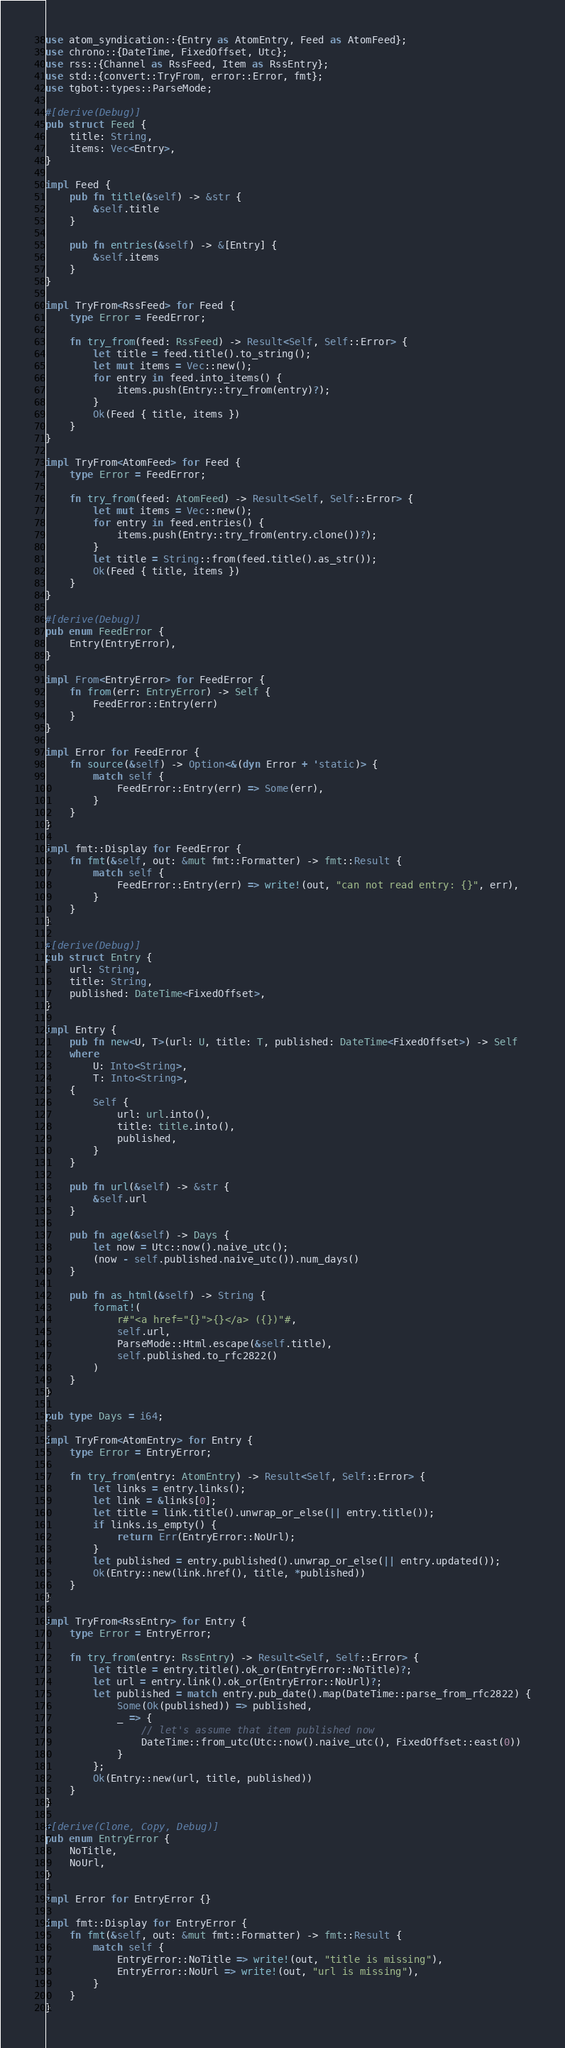<code> <loc_0><loc_0><loc_500><loc_500><_Rust_>use atom_syndication::{Entry as AtomEntry, Feed as AtomFeed};
use chrono::{DateTime, FixedOffset, Utc};
use rss::{Channel as RssFeed, Item as RssEntry};
use std::{convert::TryFrom, error::Error, fmt};
use tgbot::types::ParseMode;

#[derive(Debug)]
pub struct Feed {
    title: String,
    items: Vec<Entry>,
}

impl Feed {
    pub fn title(&self) -> &str {
        &self.title
    }

    pub fn entries(&self) -> &[Entry] {
        &self.items
    }
}

impl TryFrom<RssFeed> for Feed {
    type Error = FeedError;

    fn try_from(feed: RssFeed) -> Result<Self, Self::Error> {
        let title = feed.title().to_string();
        let mut items = Vec::new();
        for entry in feed.into_items() {
            items.push(Entry::try_from(entry)?);
        }
        Ok(Feed { title, items })
    }
}

impl TryFrom<AtomFeed> for Feed {
    type Error = FeedError;

    fn try_from(feed: AtomFeed) -> Result<Self, Self::Error> {
        let mut items = Vec::new();
        for entry in feed.entries() {
            items.push(Entry::try_from(entry.clone())?);
        }
        let title = String::from(feed.title().as_str());
        Ok(Feed { title, items })
    }
}

#[derive(Debug)]
pub enum FeedError {
    Entry(EntryError),
}

impl From<EntryError> for FeedError {
    fn from(err: EntryError) -> Self {
        FeedError::Entry(err)
    }
}

impl Error for FeedError {
    fn source(&self) -> Option<&(dyn Error + 'static)> {
        match self {
            FeedError::Entry(err) => Some(err),
        }
    }
}

impl fmt::Display for FeedError {
    fn fmt(&self, out: &mut fmt::Formatter) -> fmt::Result {
        match self {
            FeedError::Entry(err) => write!(out, "can not read entry: {}", err),
        }
    }
}

#[derive(Debug)]
pub struct Entry {
    url: String,
    title: String,
    published: DateTime<FixedOffset>,
}

impl Entry {
    pub fn new<U, T>(url: U, title: T, published: DateTime<FixedOffset>) -> Self
    where
        U: Into<String>,
        T: Into<String>,
    {
        Self {
            url: url.into(),
            title: title.into(),
            published,
        }
    }

    pub fn url(&self) -> &str {
        &self.url
    }

    pub fn age(&self) -> Days {
        let now = Utc::now().naive_utc();
        (now - self.published.naive_utc()).num_days()
    }

    pub fn as_html(&self) -> String {
        format!(
            r#"<a href="{}">{}</a> ({})"#,
            self.url,
            ParseMode::Html.escape(&self.title),
            self.published.to_rfc2822()
        )
    }
}

pub type Days = i64;

impl TryFrom<AtomEntry> for Entry {
    type Error = EntryError;

    fn try_from(entry: AtomEntry) -> Result<Self, Self::Error> {
        let links = entry.links();
        let link = &links[0];
        let title = link.title().unwrap_or_else(|| entry.title());
        if links.is_empty() {
            return Err(EntryError::NoUrl);
        }
        let published = entry.published().unwrap_or_else(|| entry.updated());
        Ok(Entry::new(link.href(), title, *published))
    }
}

impl TryFrom<RssEntry> for Entry {
    type Error = EntryError;

    fn try_from(entry: RssEntry) -> Result<Self, Self::Error> {
        let title = entry.title().ok_or(EntryError::NoTitle)?;
        let url = entry.link().ok_or(EntryError::NoUrl)?;
        let published = match entry.pub_date().map(DateTime::parse_from_rfc2822) {
            Some(Ok(published)) => published,
            _ => {
                // let's assume that item published now
                DateTime::from_utc(Utc::now().naive_utc(), FixedOffset::east(0))
            }
        };
        Ok(Entry::new(url, title, published))
    }
}

#[derive(Clone, Copy, Debug)]
pub enum EntryError {
    NoTitle,
    NoUrl,
}

impl Error for EntryError {}

impl fmt::Display for EntryError {
    fn fmt(&self, out: &mut fmt::Formatter) -> fmt::Result {
        match self {
            EntryError::NoTitle => write!(out, "title is missing"),
            EntryError::NoUrl => write!(out, "url is missing"),
        }
    }
}
</code> 